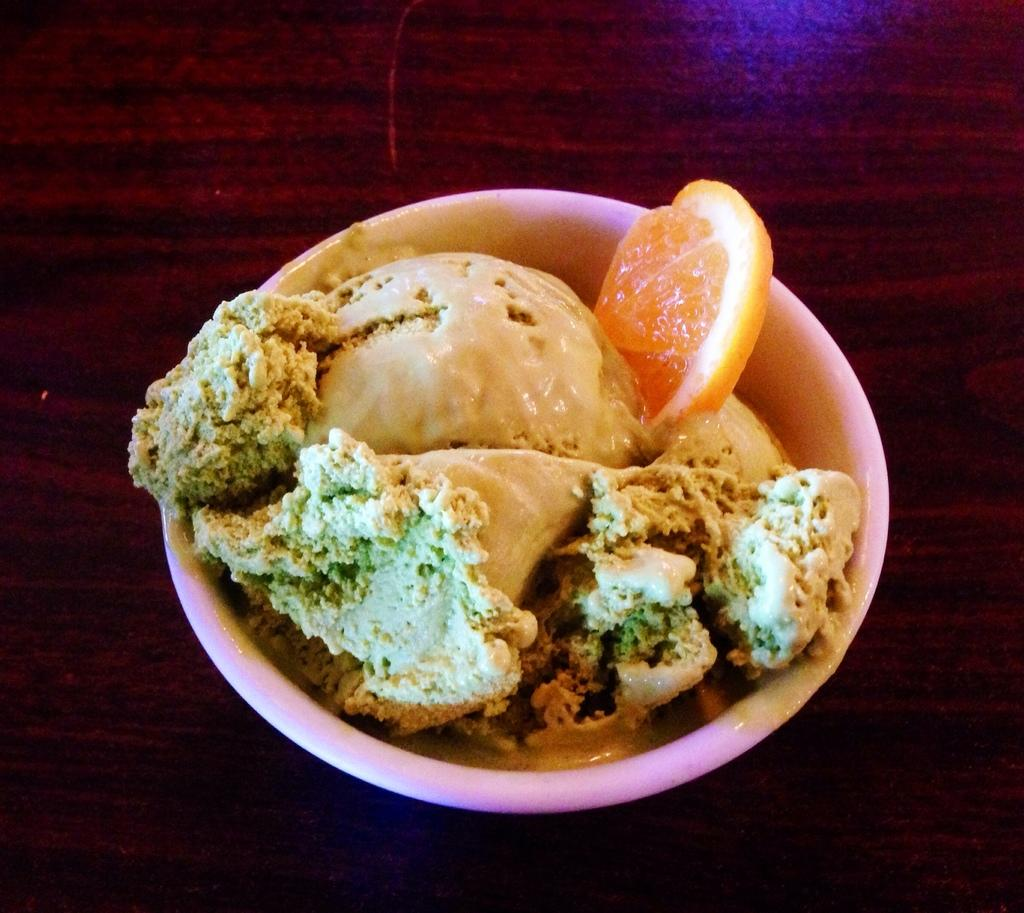What is in the bowl that is visible in the image? There is a bowl with ice cream in the image. What additional item can be seen in the bowl? There is an orange slice in the bowl. Where is the bowl located in the image? The bowl is placed on a table. What material is the table made of? The table is made of wood. How many oranges are in the sack on the table in the image? There is no sack or oranges present in the image; it only features a bowl of ice cream with an orange slice and a wooden table. 